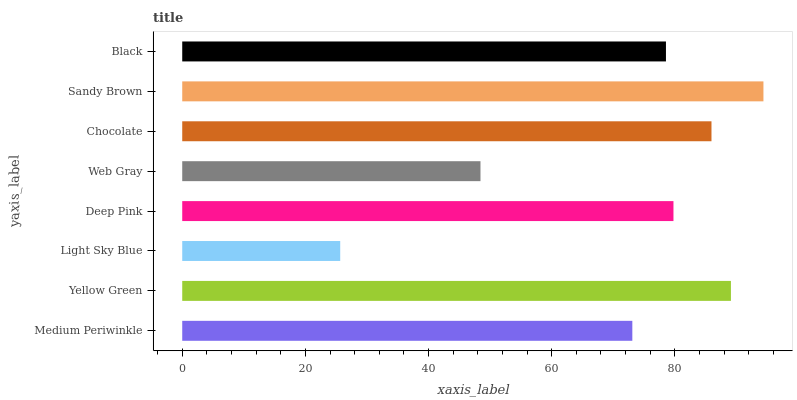Is Light Sky Blue the minimum?
Answer yes or no. Yes. Is Sandy Brown the maximum?
Answer yes or no. Yes. Is Yellow Green the minimum?
Answer yes or no. No. Is Yellow Green the maximum?
Answer yes or no. No. Is Yellow Green greater than Medium Periwinkle?
Answer yes or no. Yes. Is Medium Periwinkle less than Yellow Green?
Answer yes or no. Yes. Is Medium Periwinkle greater than Yellow Green?
Answer yes or no. No. Is Yellow Green less than Medium Periwinkle?
Answer yes or no. No. Is Deep Pink the high median?
Answer yes or no. Yes. Is Black the low median?
Answer yes or no. Yes. Is Web Gray the high median?
Answer yes or no. No. Is Medium Periwinkle the low median?
Answer yes or no. No. 